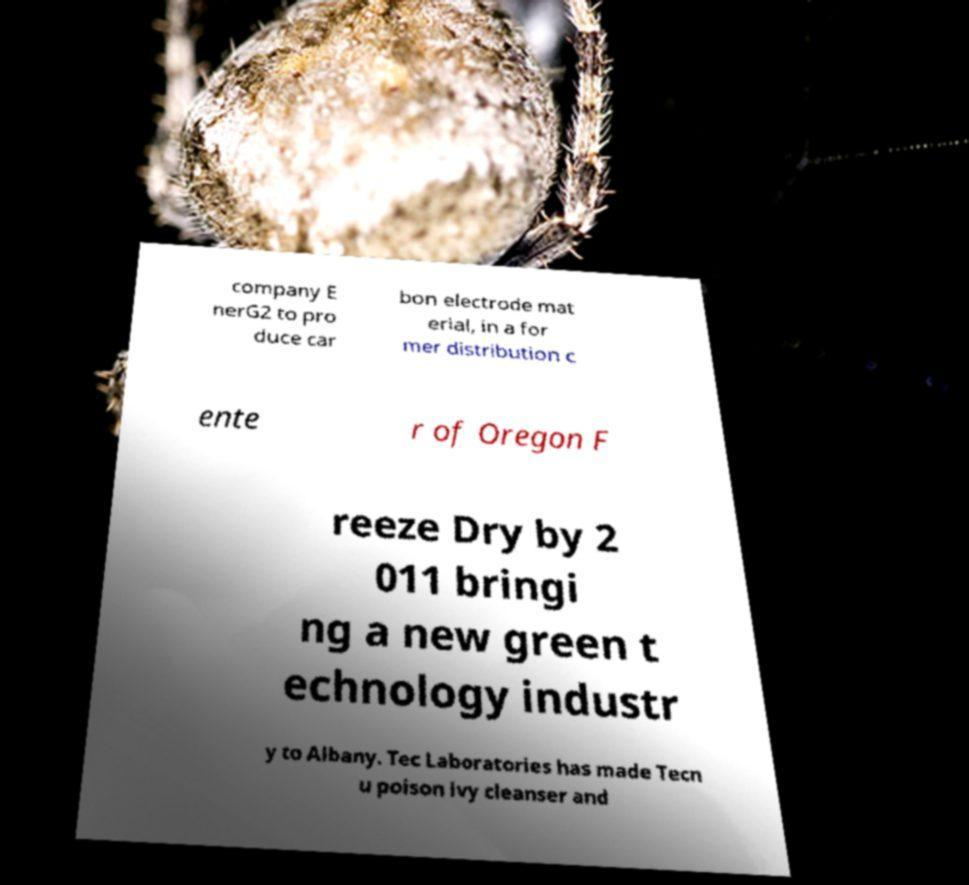Please identify and transcribe the text found in this image. company E nerG2 to pro duce car bon electrode mat erial, in a for mer distribution c ente r of Oregon F reeze Dry by 2 011 bringi ng a new green t echnology industr y to Albany. Tec Laboratories has made Tecn u poison ivy cleanser and 